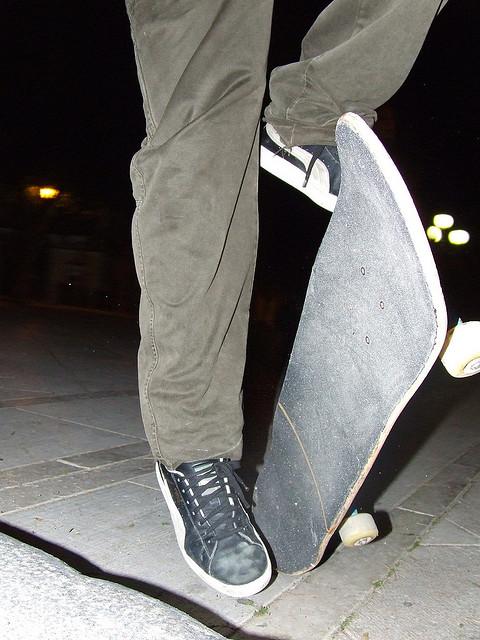What are the two letters shown on the ground?
Quick response, please. None. How many wheels on the skateboard?
Short answer required. 4. What color is the skateboard?
Keep it brief. Black. Is this guy a good skateboarder?
Be succinct. Yes. What is he doing?
Give a very brief answer. Skateboarding. 